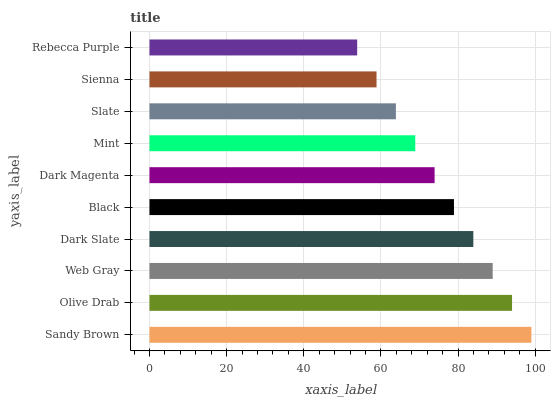Is Rebecca Purple the minimum?
Answer yes or no. Yes. Is Sandy Brown the maximum?
Answer yes or no. Yes. Is Olive Drab the minimum?
Answer yes or no. No. Is Olive Drab the maximum?
Answer yes or no. No. Is Sandy Brown greater than Olive Drab?
Answer yes or no. Yes. Is Olive Drab less than Sandy Brown?
Answer yes or no. Yes. Is Olive Drab greater than Sandy Brown?
Answer yes or no. No. Is Sandy Brown less than Olive Drab?
Answer yes or no. No. Is Black the high median?
Answer yes or no. Yes. Is Dark Magenta the low median?
Answer yes or no. Yes. Is Olive Drab the high median?
Answer yes or no. No. Is Black the low median?
Answer yes or no. No. 